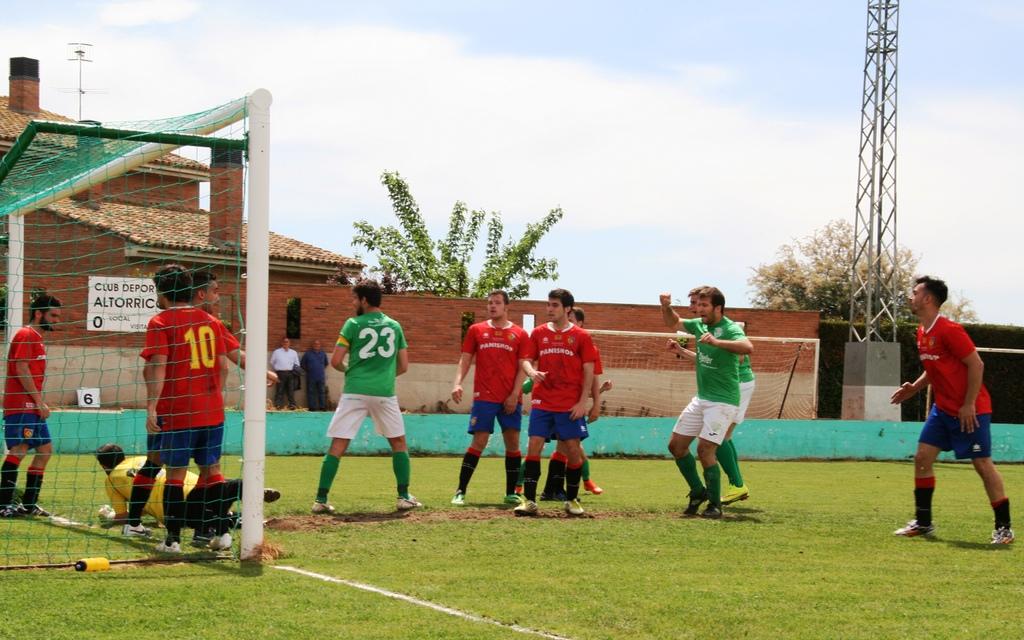What number is in red and standing in the goal?
Provide a succinct answer. 10. What color of the keeper shirt?
Ensure brevity in your answer.  Yellow. 